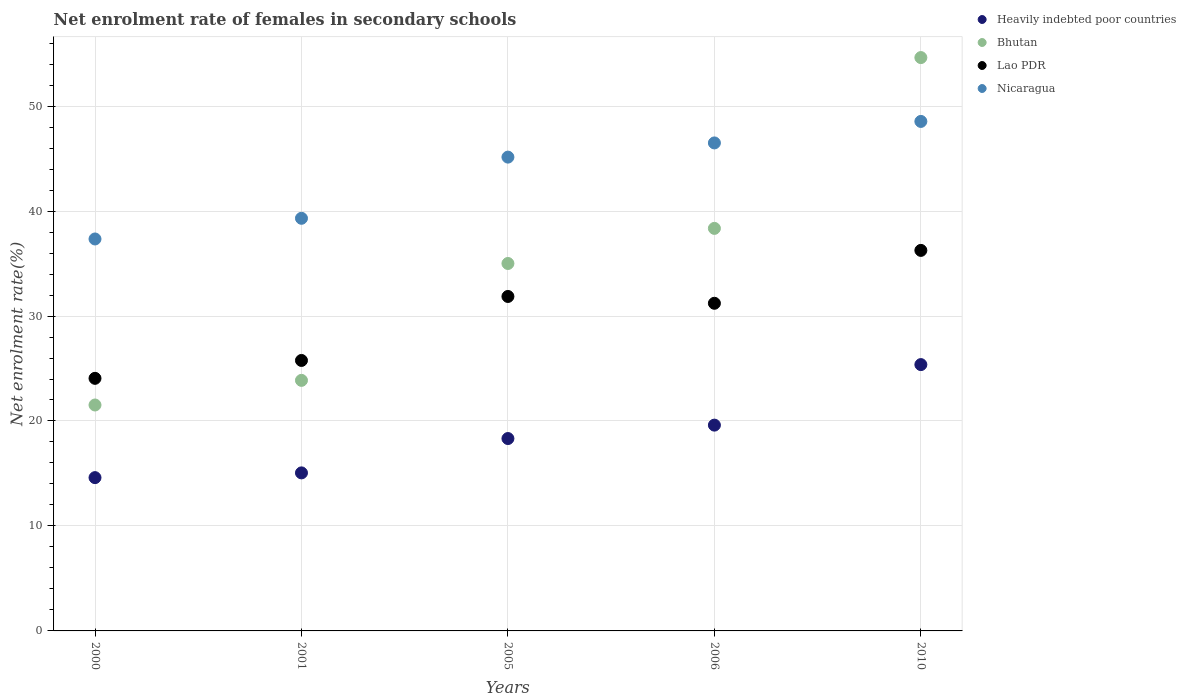What is the net enrolment rate of females in secondary schools in Bhutan in 2010?
Offer a very short reply. 54.62. Across all years, what is the maximum net enrolment rate of females in secondary schools in Nicaragua?
Offer a very short reply. 48.54. Across all years, what is the minimum net enrolment rate of females in secondary schools in Heavily indebted poor countries?
Offer a very short reply. 14.6. In which year was the net enrolment rate of females in secondary schools in Bhutan maximum?
Your answer should be compact. 2010. In which year was the net enrolment rate of females in secondary schools in Heavily indebted poor countries minimum?
Your answer should be very brief. 2000. What is the total net enrolment rate of females in secondary schools in Heavily indebted poor countries in the graph?
Offer a terse response. 92.97. What is the difference between the net enrolment rate of females in secondary schools in Bhutan in 2000 and that in 2006?
Keep it short and to the point. -16.83. What is the difference between the net enrolment rate of females in secondary schools in Lao PDR in 2001 and the net enrolment rate of females in secondary schools in Nicaragua in 2005?
Make the answer very short. -19.37. What is the average net enrolment rate of females in secondary schools in Nicaragua per year?
Your answer should be compact. 43.36. In the year 2001, what is the difference between the net enrolment rate of females in secondary schools in Nicaragua and net enrolment rate of females in secondary schools in Lao PDR?
Make the answer very short. 13.54. In how many years, is the net enrolment rate of females in secondary schools in Nicaragua greater than 52 %?
Offer a very short reply. 0. What is the ratio of the net enrolment rate of females in secondary schools in Lao PDR in 2000 to that in 2001?
Offer a very short reply. 0.93. Is the difference between the net enrolment rate of females in secondary schools in Nicaragua in 2005 and 2006 greater than the difference between the net enrolment rate of females in secondary schools in Lao PDR in 2005 and 2006?
Your response must be concise. No. What is the difference between the highest and the second highest net enrolment rate of females in secondary schools in Bhutan?
Your answer should be compact. 16.27. What is the difference between the highest and the lowest net enrolment rate of females in secondary schools in Bhutan?
Provide a succinct answer. 33.1. In how many years, is the net enrolment rate of females in secondary schools in Nicaragua greater than the average net enrolment rate of females in secondary schools in Nicaragua taken over all years?
Ensure brevity in your answer.  3. Is it the case that in every year, the sum of the net enrolment rate of females in secondary schools in Nicaragua and net enrolment rate of females in secondary schools in Lao PDR  is greater than the sum of net enrolment rate of females in secondary schools in Heavily indebted poor countries and net enrolment rate of females in secondary schools in Bhutan?
Your answer should be compact. No. Is it the case that in every year, the sum of the net enrolment rate of females in secondary schools in Lao PDR and net enrolment rate of females in secondary schools in Heavily indebted poor countries  is greater than the net enrolment rate of females in secondary schools in Nicaragua?
Your answer should be very brief. Yes. Is the net enrolment rate of females in secondary schools in Nicaragua strictly greater than the net enrolment rate of females in secondary schools in Lao PDR over the years?
Your answer should be very brief. Yes. What is the difference between two consecutive major ticks on the Y-axis?
Keep it short and to the point. 10. Where does the legend appear in the graph?
Give a very brief answer. Top right. How are the legend labels stacked?
Provide a short and direct response. Vertical. What is the title of the graph?
Your answer should be compact. Net enrolment rate of females in secondary schools. What is the label or title of the X-axis?
Provide a short and direct response. Years. What is the label or title of the Y-axis?
Your response must be concise. Net enrolment rate(%). What is the Net enrolment rate(%) in Heavily indebted poor countries in 2000?
Offer a terse response. 14.6. What is the Net enrolment rate(%) in Bhutan in 2000?
Keep it short and to the point. 21.52. What is the Net enrolment rate(%) of Lao PDR in 2000?
Keep it short and to the point. 24.06. What is the Net enrolment rate(%) in Nicaragua in 2000?
Your answer should be compact. 37.34. What is the Net enrolment rate(%) of Heavily indebted poor countries in 2001?
Ensure brevity in your answer.  15.06. What is the Net enrolment rate(%) in Bhutan in 2001?
Provide a succinct answer. 23.87. What is the Net enrolment rate(%) in Lao PDR in 2001?
Your response must be concise. 25.77. What is the Net enrolment rate(%) of Nicaragua in 2001?
Offer a terse response. 39.31. What is the Net enrolment rate(%) in Heavily indebted poor countries in 2005?
Provide a short and direct response. 18.33. What is the Net enrolment rate(%) in Bhutan in 2005?
Offer a terse response. 35.01. What is the Net enrolment rate(%) of Lao PDR in 2005?
Provide a succinct answer. 31.86. What is the Net enrolment rate(%) of Nicaragua in 2005?
Provide a succinct answer. 45.14. What is the Net enrolment rate(%) in Heavily indebted poor countries in 2006?
Your answer should be very brief. 19.61. What is the Net enrolment rate(%) in Bhutan in 2006?
Your answer should be very brief. 38.35. What is the Net enrolment rate(%) of Lao PDR in 2006?
Give a very brief answer. 31.21. What is the Net enrolment rate(%) of Nicaragua in 2006?
Offer a terse response. 46.49. What is the Net enrolment rate(%) in Heavily indebted poor countries in 2010?
Keep it short and to the point. 25.37. What is the Net enrolment rate(%) in Bhutan in 2010?
Your answer should be compact. 54.62. What is the Net enrolment rate(%) of Lao PDR in 2010?
Your response must be concise. 36.25. What is the Net enrolment rate(%) in Nicaragua in 2010?
Your response must be concise. 48.54. Across all years, what is the maximum Net enrolment rate(%) in Heavily indebted poor countries?
Your answer should be compact. 25.37. Across all years, what is the maximum Net enrolment rate(%) of Bhutan?
Your response must be concise. 54.62. Across all years, what is the maximum Net enrolment rate(%) in Lao PDR?
Your response must be concise. 36.25. Across all years, what is the maximum Net enrolment rate(%) of Nicaragua?
Your answer should be very brief. 48.54. Across all years, what is the minimum Net enrolment rate(%) in Heavily indebted poor countries?
Offer a terse response. 14.6. Across all years, what is the minimum Net enrolment rate(%) in Bhutan?
Keep it short and to the point. 21.52. Across all years, what is the minimum Net enrolment rate(%) of Lao PDR?
Your answer should be compact. 24.06. Across all years, what is the minimum Net enrolment rate(%) in Nicaragua?
Ensure brevity in your answer.  37.34. What is the total Net enrolment rate(%) in Heavily indebted poor countries in the graph?
Your response must be concise. 92.97. What is the total Net enrolment rate(%) of Bhutan in the graph?
Your answer should be compact. 173.37. What is the total Net enrolment rate(%) of Lao PDR in the graph?
Your answer should be very brief. 149.16. What is the total Net enrolment rate(%) of Nicaragua in the graph?
Offer a very short reply. 216.82. What is the difference between the Net enrolment rate(%) in Heavily indebted poor countries in 2000 and that in 2001?
Provide a short and direct response. -0.45. What is the difference between the Net enrolment rate(%) in Bhutan in 2000 and that in 2001?
Your response must be concise. -2.35. What is the difference between the Net enrolment rate(%) of Lao PDR in 2000 and that in 2001?
Your answer should be compact. -1.7. What is the difference between the Net enrolment rate(%) in Nicaragua in 2000 and that in 2001?
Offer a terse response. -1.97. What is the difference between the Net enrolment rate(%) in Heavily indebted poor countries in 2000 and that in 2005?
Offer a very short reply. -3.72. What is the difference between the Net enrolment rate(%) in Bhutan in 2000 and that in 2005?
Make the answer very short. -13.48. What is the difference between the Net enrolment rate(%) of Lao PDR in 2000 and that in 2005?
Your response must be concise. -7.8. What is the difference between the Net enrolment rate(%) in Nicaragua in 2000 and that in 2005?
Your response must be concise. -7.8. What is the difference between the Net enrolment rate(%) of Heavily indebted poor countries in 2000 and that in 2006?
Ensure brevity in your answer.  -5. What is the difference between the Net enrolment rate(%) of Bhutan in 2000 and that in 2006?
Your response must be concise. -16.83. What is the difference between the Net enrolment rate(%) in Lao PDR in 2000 and that in 2006?
Your answer should be very brief. -7.15. What is the difference between the Net enrolment rate(%) of Nicaragua in 2000 and that in 2006?
Offer a terse response. -9.15. What is the difference between the Net enrolment rate(%) in Heavily indebted poor countries in 2000 and that in 2010?
Provide a short and direct response. -10.77. What is the difference between the Net enrolment rate(%) in Bhutan in 2000 and that in 2010?
Offer a terse response. -33.1. What is the difference between the Net enrolment rate(%) of Lao PDR in 2000 and that in 2010?
Offer a terse response. -12.19. What is the difference between the Net enrolment rate(%) in Nicaragua in 2000 and that in 2010?
Your response must be concise. -11.2. What is the difference between the Net enrolment rate(%) in Heavily indebted poor countries in 2001 and that in 2005?
Provide a succinct answer. -3.27. What is the difference between the Net enrolment rate(%) in Bhutan in 2001 and that in 2005?
Offer a very short reply. -11.14. What is the difference between the Net enrolment rate(%) of Lao PDR in 2001 and that in 2005?
Provide a succinct answer. -6.1. What is the difference between the Net enrolment rate(%) in Nicaragua in 2001 and that in 2005?
Your answer should be very brief. -5.83. What is the difference between the Net enrolment rate(%) of Heavily indebted poor countries in 2001 and that in 2006?
Offer a terse response. -4.55. What is the difference between the Net enrolment rate(%) in Bhutan in 2001 and that in 2006?
Offer a terse response. -14.48. What is the difference between the Net enrolment rate(%) in Lao PDR in 2001 and that in 2006?
Provide a succinct answer. -5.45. What is the difference between the Net enrolment rate(%) in Nicaragua in 2001 and that in 2006?
Provide a short and direct response. -7.18. What is the difference between the Net enrolment rate(%) of Heavily indebted poor countries in 2001 and that in 2010?
Your answer should be very brief. -10.32. What is the difference between the Net enrolment rate(%) of Bhutan in 2001 and that in 2010?
Your answer should be very brief. -30.75. What is the difference between the Net enrolment rate(%) in Lao PDR in 2001 and that in 2010?
Offer a terse response. -10.49. What is the difference between the Net enrolment rate(%) of Nicaragua in 2001 and that in 2010?
Offer a terse response. -9.23. What is the difference between the Net enrolment rate(%) of Heavily indebted poor countries in 2005 and that in 2006?
Make the answer very short. -1.28. What is the difference between the Net enrolment rate(%) in Bhutan in 2005 and that in 2006?
Your response must be concise. -3.34. What is the difference between the Net enrolment rate(%) in Lao PDR in 2005 and that in 2006?
Keep it short and to the point. 0.65. What is the difference between the Net enrolment rate(%) in Nicaragua in 2005 and that in 2006?
Keep it short and to the point. -1.35. What is the difference between the Net enrolment rate(%) in Heavily indebted poor countries in 2005 and that in 2010?
Provide a succinct answer. -7.04. What is the difference between the Net enrolment rate(%) in Bhutan in 2005 and that in 2010?
Keep it short and to the point. -19.62. What is the difference between the Net enrolment rate(%) in Lao PDR in 2005 and that in 2010?
Keep it short and to the point. -4.39. What is the difference between the Net enrolment rate(%) of Nicaragua in 2005 and that in 2010?
Your response must be concise. -3.4. What is the difference between the Net enrolment rate(%) in Heavily indebted poor countries in 2006 and that in 2010?
Offer a very short reply. -5.77. What is the difference between the Net enrolment rate(%) in Bhutan in 2006 and that in 2010?
Make the answer very short. -16.27. What is the difference between the Net enrolment rate(%) in Lao PDR in 2006 and that in 2010?
Ensure brevity in your answer.  -5.04. What is the difference between the Net enrolment rate(%) in Nicaragua in 2006 and that in 2010?
Your response must be concise. -2.05. What is the difference between the Net enrolment rate(%) of Heavily indebted poor countries in 2000 and the Net enrolment rate(%) of Bhutan in 2001?
Provide a succinct answer. -9.27. What is the difference between the Net enrolment rate(%) in Heavily indebted poor countries in 2000 and the Net enrolment rate(%) in Lao PDR in 2001?
Provide a short and direct response. -11.16. What is the difference between the Net enrolment rate(%) of Heavily indebted poor countries in 2000 and the Net enrolment rate(%) of Nicaragua in 2001?
Offer a very short reply. -24.71. What is the difference between the Net enrolment rate(%) of Bhutan in 2000 and the Net enrolment rate(%) of Lao PDR in 2001?
Your answer should be compact. -4.24. What is the difference between the Net enrolment rate(%) in Bhutan in 2000 and the Net enrolment rate(%) in Nicaragua in 2001?
Keep it short and to the point. -17.79. What is the difference between the Net enrolment rate(%) in Lao PDR in 2000 and the Net enrolment rate(%) in Nicaragua in 2001?
Offer a very short reply. -15.25. What is the difference between the Net enrolment rate(%) of Heavily indebted poor countries in 2000 and the Net enrolment rate(%) of Bhutan in 2005?
Your answer should be very brief. -20.4. What is the difference between the Net enrolment rate(%) of Heavily indebted poor countries in 2000 and the Net enrolment rate(%) of Lao PDR in 2005?
Ensure brevity in your answer.  -17.26. What is the difference between the Net enrolment rate(%) in Heavily indebted poor countries in 2000 and the Net enrolment rate(%) in Nicaragua in 2005?
Provide a succinct answer. -30.53. What is the difference between the Net enrolment rate(%) of Bhutan in 2000 and the Net enrolment rate(%) of Lao PDR in 2005?
Provide a succinct answer. -10.34. What is the difference between the Net enrolment rate(%) in Bhutan in 2000 and the Net enrolment rate(%) in Nicaragua in 2005?
Your answer should be very brief. -23.61. What is the difference between the Net enrolment rate(%) in Lao PDR in 2000 and the Net enrolment rate(%) in Nicaragua in 2005?
Your answer should be very brief. -21.07. What is the difference between the Net enrolment rate(%) of Heavily indebted poor countries in 2000 and the Net enrolment rate(%) of Bhutan in 2006?
Ensure brevity in your answer.  -23.75. What is the difference between the Net enrolment rate(%) in Heavily indebted poor countries in 2000 and the Net enrolment rate(%) in Lao PDR in 2006?
Offer a terse response. -16.61. What is the difference between the Net enrolment rate(%) in Heavily indebted poor countries in 2000 and the Net enrolment rate(%) in Nicaragua in 2006?
Offer a very short reply. -31.89. What is the difference between the Net enrolment rate(%) in Bhutan in 2000 and the Net enrolment rate(%) in Lao PDR in 2006?
Your response must be concise. -9.69. What is the difference between the Net enrolment rate(%) of Bhutan in 2000 and the Net enrolment rate(%) of Nicaragua in 2006?
Provide a short and direct response. -24.97. What is the difference between the Net enrolment rate(%) of Lao PDR in 2000 and the Net enrolment rate(%) of Nicaragua in 2006?
Make the answer very short. -22.43. What is the difference between the Net enrolment rate(%) in Heavily indebted poor countries in 2000 and the Net enrolment rate(%) in Bhutan in 2010?
Ensure brevity in your answer.  -40.02. What is the difference between the Net enrolment rate(%) in Heavily indebted poor countries in 2000 and the Net enrolment rate(%) in Lao PDR in 2010?
Provide a succinct answer. -21.65. What is the difference between the Net enrolment rate(%) in Heavily indebted poor countries in 2000 and the Net enrolment rate(%) in Nicaragua in 2010?
Your answer should be very brief. -33.94. What is the difference between the Net enrolment rate(%) of Bhutan in 2000 and the Net enrolment rate(%) of Lao PDR in 2010?
Your answer should be compact. -14.73. What is the difference between the Net enrolment rate(%) of Bhutan in 2000 and the Net enrolment rate(%) of Nicaragua in 2010?
Keep it short and to the point. -27.02. What is the difference between the Net enrolment rate(%) of Lao PDR in 2000 and the Net enrolment rate(%) of Nicaragua in 2010?
Your answer should be compact. -24.48. What is the difference between the Net enrolment rate(%) of Heavily indebted poor countries in 2001 and the Net enrolment rate(%) of Bhutan in 2005?
Your answer should be very brief. -19.95. What is the difference between the Net enrolment rate(%) in Heavily indebted poor countries in 2001 and the Net enrolment rate(%) in Lao PDR in 2005?
Give a very brief answer. -16.81. What is the difference between the Net enrolment rate(%) in Heavily indebted poor countries in 2001 and the Net enrolment rate(%) in Nicaragua in 2005?
Provide a succinct answer. -30.08. What is the difference between the Net enrolment rate(%) in Bhutan in 2001 and the Net enrolment rate(%) in Lao PDR in 2005?
Make the answer very short. -7.99. What is the difference between the Net enrolment rate(%) in Bhutan in 2001 and the Net enrolment rate(%) in Nicaragua in 2005?
Your response must be concise. -21.27. What is the difference between the Net enrolment rate(%) of Lao PDR in 2001 and the Net enrolment rate(%) of Nicaragua in 2005?
Make the answer very short. -19.37. What is the difference between the Net enrolment rate(%) of Heavily indebted poor countries in 2001 and the Net enrolment rate(%) of Bhutan in 2006?
Keep it short and to the point. -23.29. What is the difference between the Net enrolment rate(%) in Heavily indebted poor countries in 2001 and the Net enrolment rate(%) in Lao PDR in 2006?
Your response must be concise. -16.16. What is the difference between the Net enrolment rate(%) of Heavily indebted poor countries in 2001 and the Net enrolment rate(%) of Nicaragua in 2006?
Make the answer very short. -31.43. What is the difference between the Net enrolment rate(%) in Bhutan in 2001 and the Net enrolment rate(%) in Lao PDR in 2006?
Provide a short and direct response. -7.34. What is the difference between the Net enrolment rate(%) of Bhutan in 2001 and the Net enrolment rate(%) of Nicaragua in 2006?
Offer a very short reply. -22.62. What is the difference between the Net enrolment rate(%) in Lao PDR in 2001 and the Net enrolment rate(%) in Nicaragua in 2006?
Your response must be concise. -20.72. What is the difference between the Net enrolment rate(%) in Heavily indebted poor countries in 2001 and the Net enrolment rate(%) in Bhutan in 2010?
Make the answer very short. -39.57. What is the difference between the Net enrolment rate(%) in Heavily indebted poor countries in 2001 and the Net enrolment rate(%) in Lao PDR in 2010?
Ensure brevity in your answer.  -21.2. What is the difference between the Net enrolment rate(%) in Heavily indebted poor countries in 2001 and the Net enrolment rate(%) in Nicaragua in 2010?
Your response must be concise. -33.48. What is the difference between the Net enrolment rate(%) of Bhutan in 2001 and the Net enrolment rate(%) of Lao PDR in 2010?
Make the answer very short. -12.38. What is the difference between the Net enrolment rate(%) in Bhutan in 2001 and the Net enrolment rate(%) in Nicaragua in 2010?
Make the answer very short. -24.67. What is the difference between the Net enrolment rate(%) in Lao PDR in 2001 and the Net enrolment rate(%) in Nicaragua in 2010?
Offer a terse response. -22.77. What is the difference between the Net enrolment rate(%) of Heavily indebted poor countries in 2005 and the Net enrolment rate(%) of Bhutan in 2006?
Provide a succinct answer. -20.02. What is the difference between the Net enrolment rate(%) of Heavily indebted poor countries in 2005 and the Net enrolment rate(%) of Lao PDR in 2006?
Provide a succinct answer. -12.89. What is the difference between the Net enrolment rate(%) of Heavily indebted poor countries in 2005 and the Net enrolment rate(%) of Nicaragua in 2006?
Offer a terse response. -28.16. What is the difference between the Net enrolment rate(%) in Bhutan in 2005 and the Net enrolment rate(%) in Lao PDR in 2006?
Give a very brief answer. 3.79. What is the difference between the Net enrolment rate(%) of Bhutan in 2005 and the Net enrolment rate(%) of Nicaragua in 2006?
Offer a very short reply. -11.49. What is the difference between the Net enrolment rate(%) in Lao PDR in 2005 and the Net enrolment rate(%) in Nicaragua in 2006?
Keep it short and to the point. -14.63. What is the difference between the Net enrolment rate(%) in Heavily indebted poor countries in 2005 and the Net enrolment rate(%) in Bhutan in 2010?
Your answer should be very brief. -36.29. What is the difference between the Net enrolment rate(%) of Heavily indebted poor countries in 2005 and the Net enrolment rate(%) of Lao PDR in 2010?
Offer a terse response. -17.92. What is the difference between the Net enrolment rate(%) of Heavily indebted poor countries in 2005 and the Net enrolment rate(%) of Nicaragua in 2010?
Provide a succinct answer. -30.21. What is the difference between the Net enrolment rate(%) in Bhutan in 2005 and the Net enrolment rate(%) in Lao PDR in 2010?
Give a very brief answer. -1.25. What is the difference between the Net enrolment rate(%) of Bhutan in 2005 and the Net enrolment rate(%) of Nicaragua in 2010?
Provide a succinct answer. -13.53. What is the difference between the Net enrolment rate(%) in Lao PDR in 2005 and the Net enrolment rate(%) in Nicaragua in 2010?
Your response must be concise. -16.68. What is the difference between the Net enrolment rate(%) of Heavily indebted poor countries in 2006 and the Net enrolment rate(%) of Bhutan in 2010?
Provide a short and direct response. -35.02. What is the difference between the Net enrolment rate(%) of Heavily indebted poor countries in 2006 and the Net enrolment rate(%) of Lao PDR in 2010?
Your answer should be very brief. -16.65. What is the difference between the Net enrolment rate(%) in Heavily indebted poor countries in 2006 and the Net enrolment rate(%) in Nicaragua in 2010?
Offer a very short reply. -28.93. What is the difference between the Net enrolment rate(%) of Bhutan in 2006 and the Net enrolment rate(%) of Lao PDR in 2010?
Make the answer very short. 2.1. What is the difference between the Net enrolment rate(%) in Bhutan in 2006 and the Net enrolment rate(%) in Nicaragua in 2010?
Make the answer very short. -10.19. What is the difference between the Net enrolment rate(%) in Lao PDR in 2006 and the Net enrolment rate(%) in Nicaragua in 2010?
Offer a terse response. -17.32. What is the average Net enrolment rate(%) in Heavily indebted poor countries per year?
Make the answer very short. 18.59. What is the average Net enrolment rate(%) in Bhutan per year?
Provide a short and direct response. 34.67. What is the average Net enrolment rate(%) of Lao PDR per year?
Ensure brevity in your answer.  29.83. What is the average Net enrolment rate(%) in Nicaragua per year?
Ensure brevity in your answer.  43.36. In the year 2000, what is the difference between the Net enrolment rate(%) in Heavily indebted poor countries and Net enrolment rate(%) in Bhutan?
Offer a very short reply. -6.92. In the year 2000, what is the difference between the Net enrolment rate(%) in Heavily indebted poor countries and Net enrolment rate(%) in Lao PDR?
Provide a succinct answer. -9.46. In the year 2000, what is the difference between the Net enrolment rate(%) in Heavily indebted poor countries and Net enrolment rate(%) in Nicaragua?
Provide a short and direct response. -22.74. In the year 2000, what is the difference between the Net enrolment rate(%) in Bhutan and Net enrolment rate(%) in Lao PDR?
Your answer should be very brief. -2.54. In the year 2000, what is the difference between the Net enrolment rate(%) in Bhutan and Net enrolment rate(%) in Nicaragua?
Make the answer very short. -15.82. In the year 2000, what is the difference between the Net enrolment rate(%) of Lao PDR and Net enrolment rate(%) of Nicaragua?
Provide a succinct answer. -13.28. In the year 2001, what is the difference between the Net enrolment rate(%) in Heavily indebted poor countries and Net enrolment rate(%) in Bhutan?
Offer a very short reply. -8.81. In the year 2001, what is the difference between the Net enrolment rate(%) of Heavily indebted poor countries and Net enrolment rate(%) of Lao PDR?
Make the answer very short. -10.71. In the year 2001, what is the difference between the Net enrolment rate(%) in Heavily indebted poor countries and Net enrolment rate(%) in Nicaragua?
Your answer should be compact. -24.25. In the year 2001, what is the difference between the Net enrolment rate(%) in Bhutan and Net enrolment rate(%) in Lao PDR?
Offer a terse response. -1.9. In the year 2001, what is the difference between the Net enrolment rate(%) of Bhutan and Net enrolment rate(%) of Nicaragua?
Offer a very short reply. -15.44. In the year 2001, what is the difference between the Net enrolment rate(%) of Lao PDR and Net enrolment rate(%) of Nicaragua?
Give a very brief answer. -13.54. In the year 2005, what is the difference between the Net enrolment rate(%) of Heavily indebted poor countries and Net enrolment rate(%) of Bhutan?
Provide a short and direct response. -16.68. In the year 2005, what is the difference between the Net enrolment rate(%) in Heavily indebted poor countries and Net enrolment rate(%) in Lao PDR?
Offer a terse response. -13.54. In the year 2005, what is the difference between the Net enrolment rate(%) in Heavily indebted poor countries and Net enrolment rate(%) in Nicaragua?
Make the answer very short. -26.81. In the year 2005, what is the difference between the Net enrolment rate(%) of Bhutan and Net enrolment rate(%) of Lao PDR?
Provide a short and direct response. 3.14. In the year 2005, what is the difference between the Net enrolment rate(%) in Bhutan and Net enrolment rate(%) in Nicaragua?
Your answer should be compact. -10.13. In the year 2005, what is the difference between the Net enrolment rate(%) in Lao PDR and Net enrolment rate(%) in Nicaragua?
Your answer should be compact. -13.28. In the year 2006, what is the difference between the Net enrolment rate(%) in Heavily indebted poor countries and Net enrolment rate(%) in Bhutan?
Give a very brief answer. -18.74. In the year 2006, what is the difference between the Net enrolment rate(%) in Heavily indebted poor countries and Net enrolment rate(%) in Lao PDR?
Provide a succinct answer. -11.61. In the year 2006, what is the difference between the Net enrolment rate(%) in Heavily indebted poor countries and Net enrolment rate(%) in Nicaragua?
Provide a succinct answer. -26.89. In the year 2006, what is the difference between the Net enrolment rate(%) in Bhutan and Net enrolment rate(%) in Lao PDR?
Your answer should be compact. 7.14. In the year 2006, what is the difference between the Net enrolment rate(%) of Bhutan and Net enrolment rate(%) of Nicaragua?
Provide a succinct answer. -8.14. In the year 2006, what is the difference between the Net enrolment rate(%) of Lao PDR and Net enrolment rate(%) of Nicaragua?
Offer a terse response. -15.28. In the year 2010, what is the difference between the Net enrolment rate(%) of Heavily indebted poor countries and Net enrolment rate(%) of Bhutan?
Make the answer very short. -29.25. In the year 2010, what is the difference between the Net enrolment rate(%) in Heavily indebted poor countries and Net enrolment rate(%) in Lao PDR?
Your response must be concise. -10.88. In the year 2010, what is the difference between the Net enrolment rate(%) in Heavily indebted poor countries and Net enrolment rate(%) in Nicaragua?
Your answer should be very brief. -23.17. In the year 2010, what is the difference between the Net enrolment rate(%) of Bhutan and Net enrolment rate(%) of Lao PDR?
Your answer should be compact. 18.37. In the year 2010, what is the difference between the Net enrolment rate(%) of Bhutan and Net enrolment rate(%) of Nicaragua?
Keep it short and to the point. 6.08. In the year 2010, what is the difference between the Net enrolment rate(%) in Lao PDR and Net enrolment rate(%) in Nicaragua?
Your answer should be compact. -12.29. What is the ratio of the Net enrolment rate(%) in Heavily indebted poor countries in 2000 to that in 2001?
Ensure brevity in your answer.  0.97. What is the ratio of the Net enrolment rate(%) in Bhutan in 2000 to that in 2001?
Ensure brevity in your answer.  0.9. What is the ratio of the Net enrolment rate(%) of Lao PDR in 2000 to that in 2001?
Provide a succinct answer. 0.93. What is the ratio of the Net enrolment rate(%) in Nicaragua in 2000 to that in 2001?
Your response must be concise. 0.95. What is the ratio of the Net enrolment rate(%) of Heavily indebted poor countries in 2000 to that in 2005?
Your response must be concise. 0.8. What is the ratio of the Net enrolment rate(%) in Bhutan in 2000 to that in 2005?
Your answer should be very brief. 0.61. What is the ratio of the Net enrolment rate(%) of Lao PDR in 2000 to that in 2005?
Your response must be concise. 0.76. What is the ratio of the Net enrolment rate(%) of Nicaragua in 2000 to that in 2005?
Your answer should be very brief. 0.83. What is the ratio of the Net enrolment rate(%) of Heavily indebted poor countries in 2000 to that in 2006?
Your answer should be very brief. 0.74. What is the ratio of the Net enrolment rate(%) of Bhutan in 2000 to that in 2006?
Offer a terse response. 0.56. What is the ratio of the Net enrolment rate(%) of Lao PDR in 2000 to that in 2006?
Keep it short and to the point. 0.77. What is the ratio of the Net enrolment rate(%) of Nicaragua in 2000 to that in 2006?
Your response must be concise. 0.8. What is the ratio of the Net enrolment rate(%) in Heavily indebted poor countries in 2000 to that in 2010?
Provide a succinct answer. 0.58. What is the ratio of the Net enrolment rate(%) in Bhutan in 2000 to that in 2010?
Offer a very short reply. 0.39. What is the ratio of the Net enrolment rate(%) in Lao PDR in 2000 to that in 2010?
Your answer should be very brief. 0.66. What is the ratio of the Net enrolment rate(%) in Nicaragua in 2000 to that in 2010?
Provide a short and direct response. 0.77. What is the ratio of the Net enrolment rate(%) in Heavily indebted poor countries in 2001 to that in 2005?
Your answer should be very brief. 0.82. What is the ratio of the Net enrolment rate(%) in Bhutan in 2001 to that in 2005?
Your response must be concise. 0.68. What is the ratio of the Net enrolment rate(%) in Lao PDR in 2001 to that in 2005?
Offer a very short reply. 0.81. What is the ratio of the Net enrolment rate(%) of Nicaragua in 2001 to that in 2005?
Your answer should be very brief. 0.87. What is the ratio of the Net enrolment rate(%) of Heavily indebted poor countries in 2001 to that in 2006?
Provide a succinct answer. 0.77. What is the ratio of the Net enrolment rate(%) in Bhutan in 2001 to that in 2006?
Offer a terse response. 0.62. What is the ratio of the Net enrolment rate(%) in Lao PDR in 2001 to that in 2006?
Give a very brief answer. 0.83. What is the ratio of the Net enrolment rate(%) of Nicaragua in 2001 to that in 2006?
Your answer should be very brief. 0.85. What is the ratio of the Net enrolment rate(%) in Heavily indebted poor countries in 2001 to that in 2010?
Provide a short and direct response. 0.59. What is the ratio of the Net enrolment rate(%) in Bhutan in 2001 to that in 2010?
Your answer should be very brief. 0.44. What is the ratio of the Net enrolment rate(%) of Lao PDR in 2001 to that in 2010?
Offer a very short reply. 0.71. What is the ratio of the Net enrolment rate(%) of Nicaragua in 2001 to that in 2010?
Your answer should be compact. 0.81. What is the ratio of the Net enrolment rate(%) of Heavily indebted poor countries in 2005 to that in 2006?
Give a very brief answer. 0.93. What is the ratio of the Net enrolment rate(%) of Bhutan in 2005 to that in 2006?
Keep it short and to the point. 0.91. What is the ratio of the Net enrolment rate(%) in Lao PDR in 2005 to that in 2006?
Provide a succinct answer. 1.02. What is the ratio of the Net enrolment rate(%) in Nicaragua in 2005 to that in 2006?
Provide a succinct answer. 0.97. What is the ratio of the Net enrolment rate(%) in Heavily indebted poor countries in 2005 to that in 2010?
Provide a succinct answer. 0.72. What is the ratio of the Net enrolment rate(%) in Bhutan in 2005 to that in 2010?
Ensure brevity in your answer.  0.64. What is the ratio of the Net enrolment rate(%) in Lao PDR in 2005 to that in 2010?
Make the answer very short. 0.88. What is the ratio of the Net enrolment rate(%) in Nicaragua in 2005 to that in 2010?
Provide a succinct answer. 0.93. What is the ratio of the Net enrolment rate(%) in Heavily indebted poor countries in 2006 to that in 2010?
Your answer should be very brief. 0.77. What is the ratio of the Net enrolment rate(%) of Bhutan in 2006 to that in 2010?
Offer a very short reply. 0.7. What is the ratio of the Net enrolment rate(%) in Lao PDR in 2006 to that in 2010?
Keep it short and to the point. 0.86. What is the ratio of the Net enrolment rate(%) in Nicaragua in 2006 to that in 2010?
Give a very brief answer. 0.96. What is the difference between the highest and the second highest Net enrolment rate(%) in Heavily indebted poor countries?
Provide a short and direct response. 5.77. What is the difference between the highest and the second highest Net enrolment rate(%) in Bhutan?
Your answer should be compact. 16.27. What is the difference between the highest and the second highest Net enrolment rate(%) in Lao PDR?
Ensure brevity in your answer.  4.39. What is the difference between the highest and the second highest Net enrolment rate(%) in Nicaragua?
Provide a succinct answer. 2.05. What is the difference between the highest and the lowest Net enrolment rate(%) of Heavily indebted poor countries?
Offer a very short reply. 10.77. What is the difference between the highest and the lowest Net enrolment rate(%) of Bhutan?
Offer a very short reply. 33.1. What is the difference between the highest and the lowest Net enrolment rate(%) in Lao PDR?
Make the answer very short. 12.19. What is the difference between the highest and the lowest Net enrolment rate(%) in Nicaragua?
Ensure brevity in your answer.  11.2. 